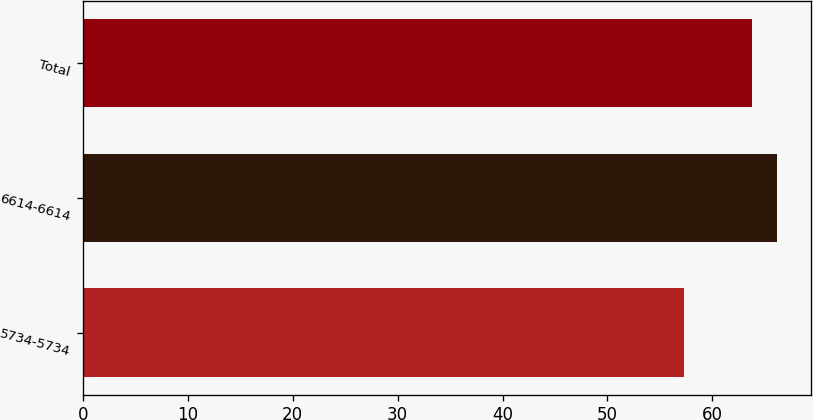Convert chart to OTSL. <chart><loc_0><loc_0><loc_500><loc_500><bar_chart><fcel>5734-5734<fcel>6614-6614<fcel>Total<nl><fcel>57.34<fcel>66.14<fcel>63.82<nl></chart> 